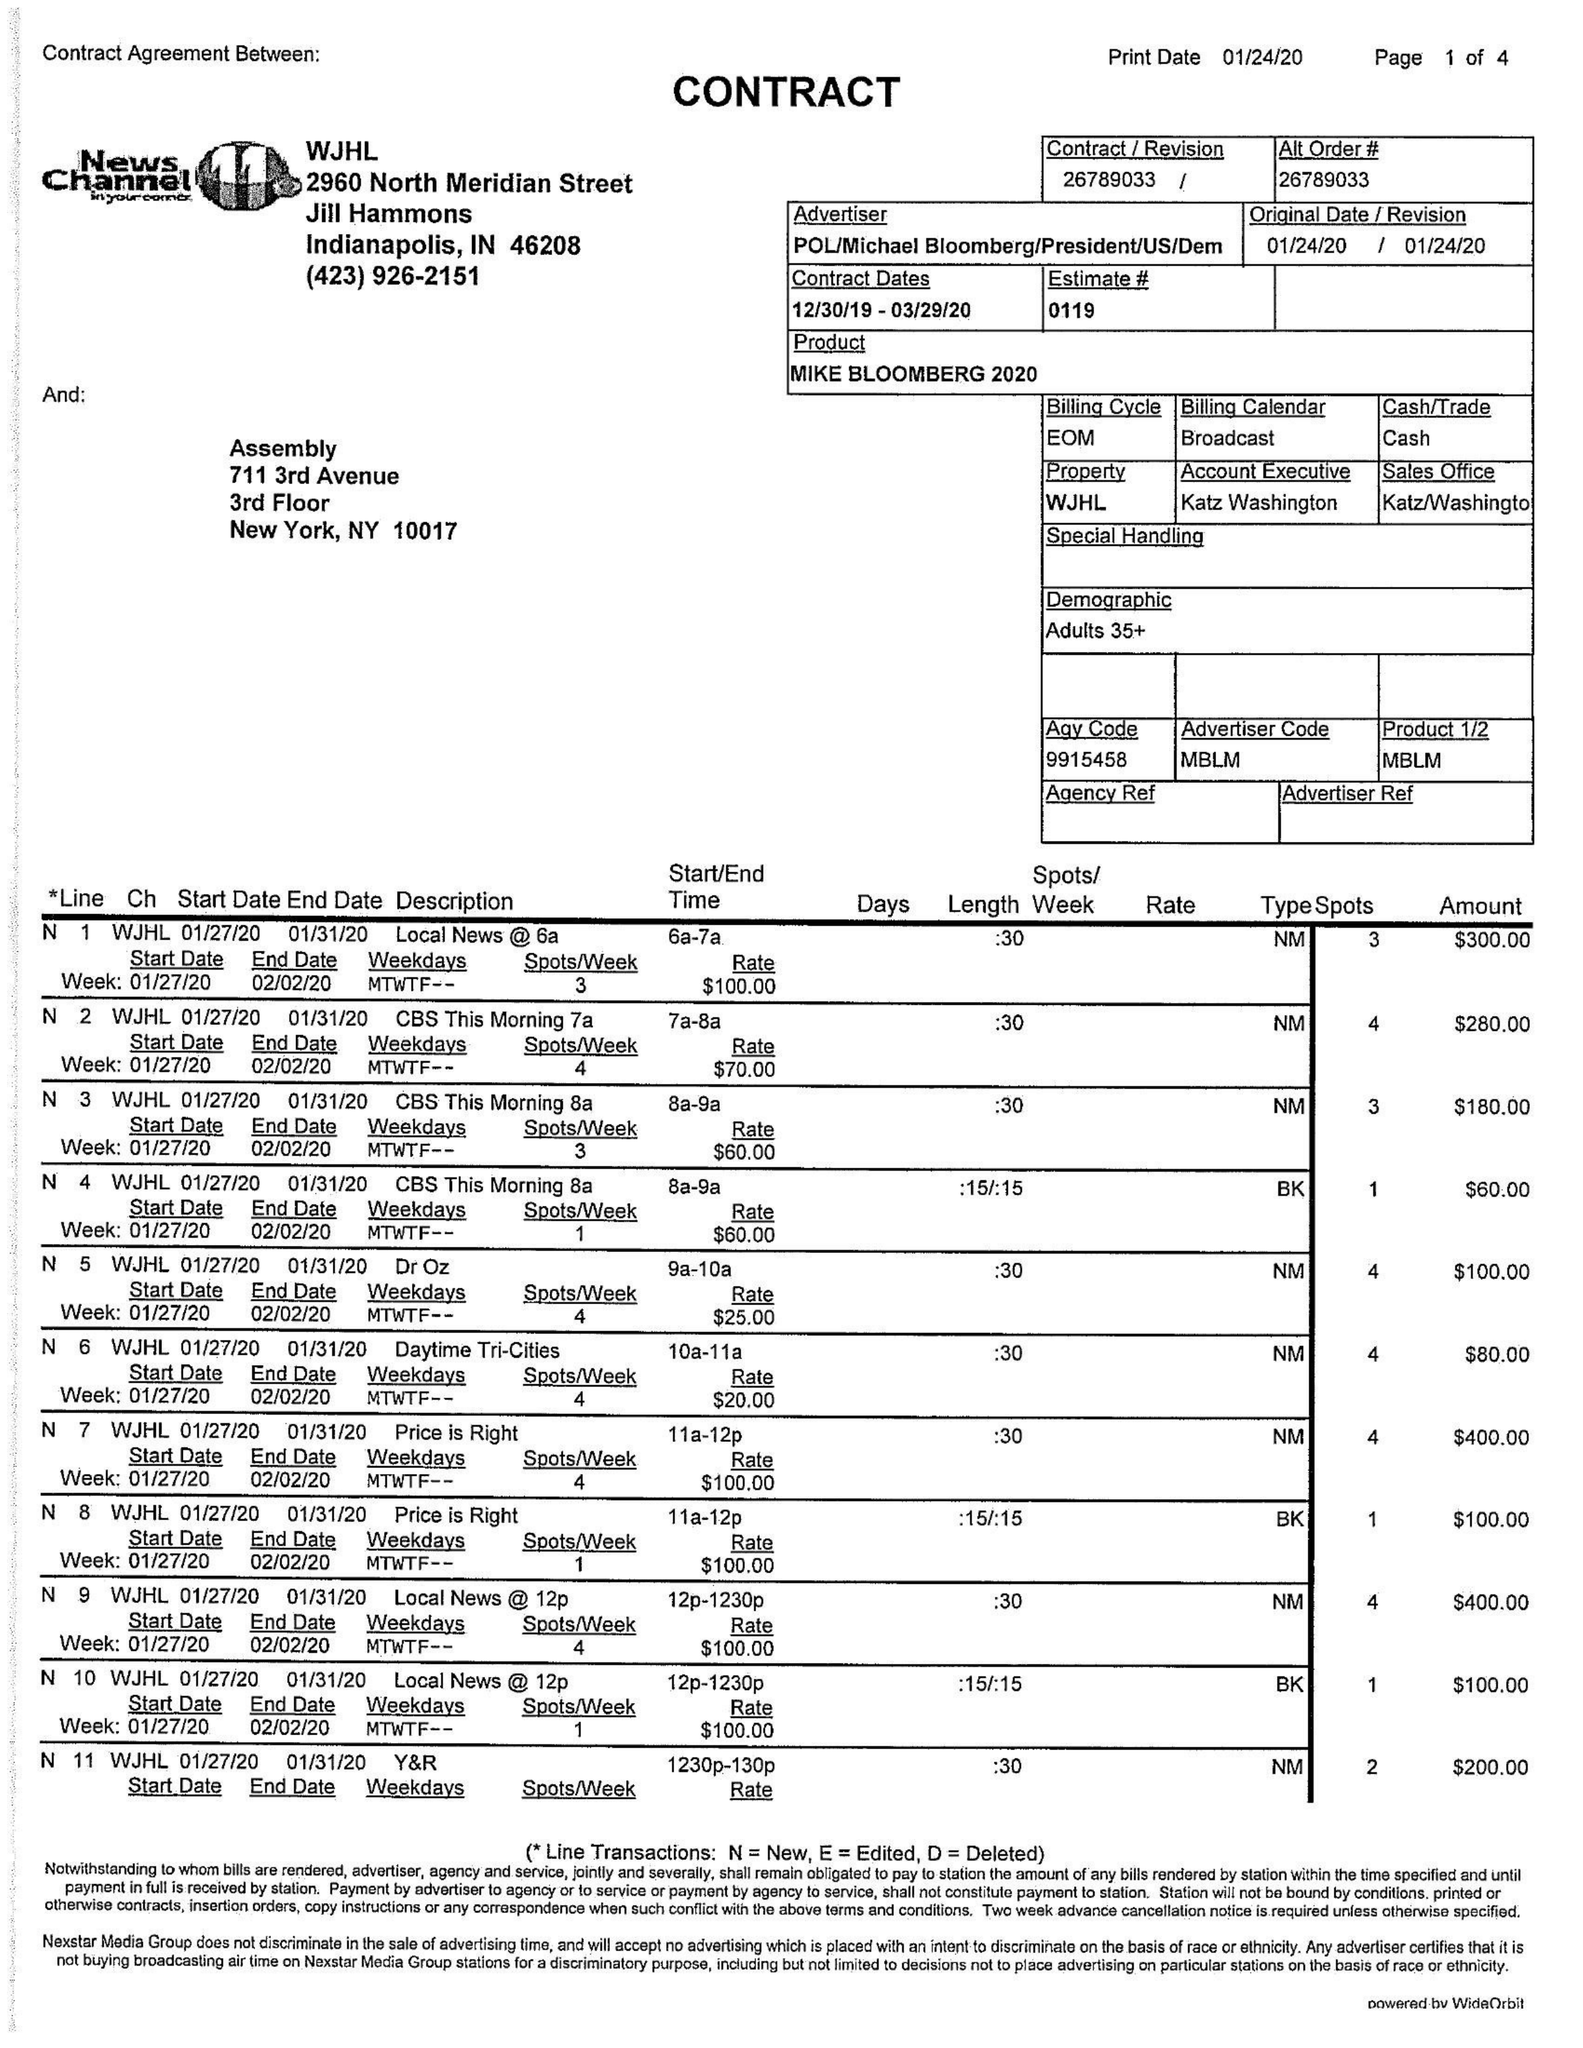What is the value for the flight_to?
Answer the question using a single word or phrase. 03/29/20 